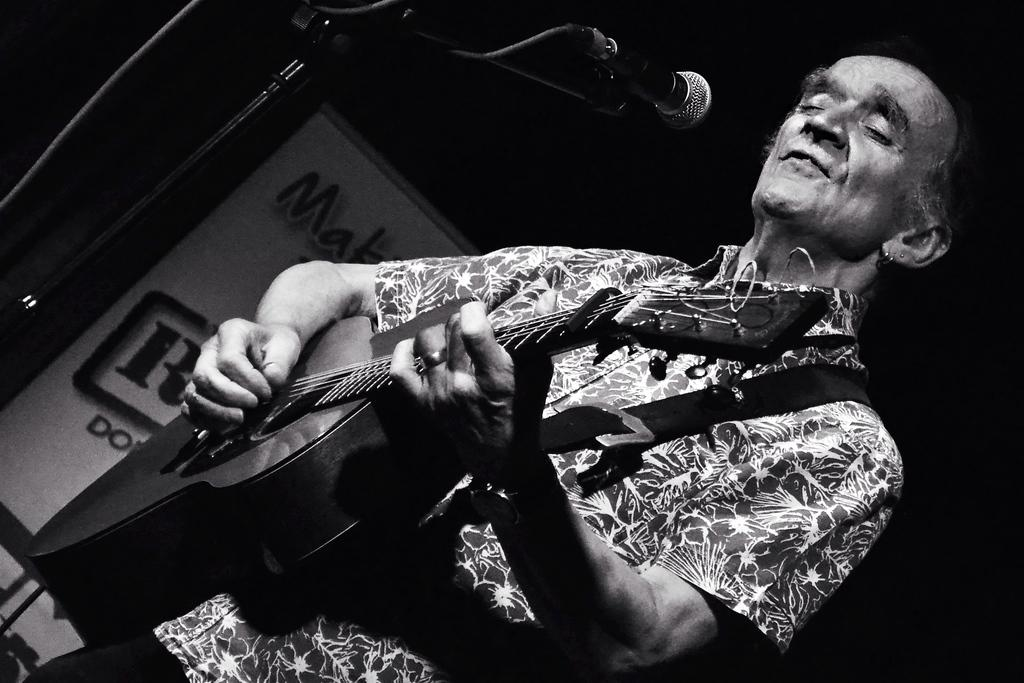What object is located on the left side of the image? There is a microphone on the left side of the image. What is the man in the image doing? The man is holding a guitar and playing it with his hands. What is the man wearing in the image? The man is wearing a shirt. Can you tell me how many balls are visible in the image? There are no balls present in the image. Is the man in the image playing a self-taught guitar technique? The image does not provide information about the guitar technique being used, so it cannot be determined if it is self-taught or not. 